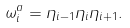<formula> <loc_0><loc_0><loc_500><loc_500>\omega _ { i } ^ { a } = \eta _ { i - 1 } \eta _ { i } \eta _ { i + 1 } .</formula> 